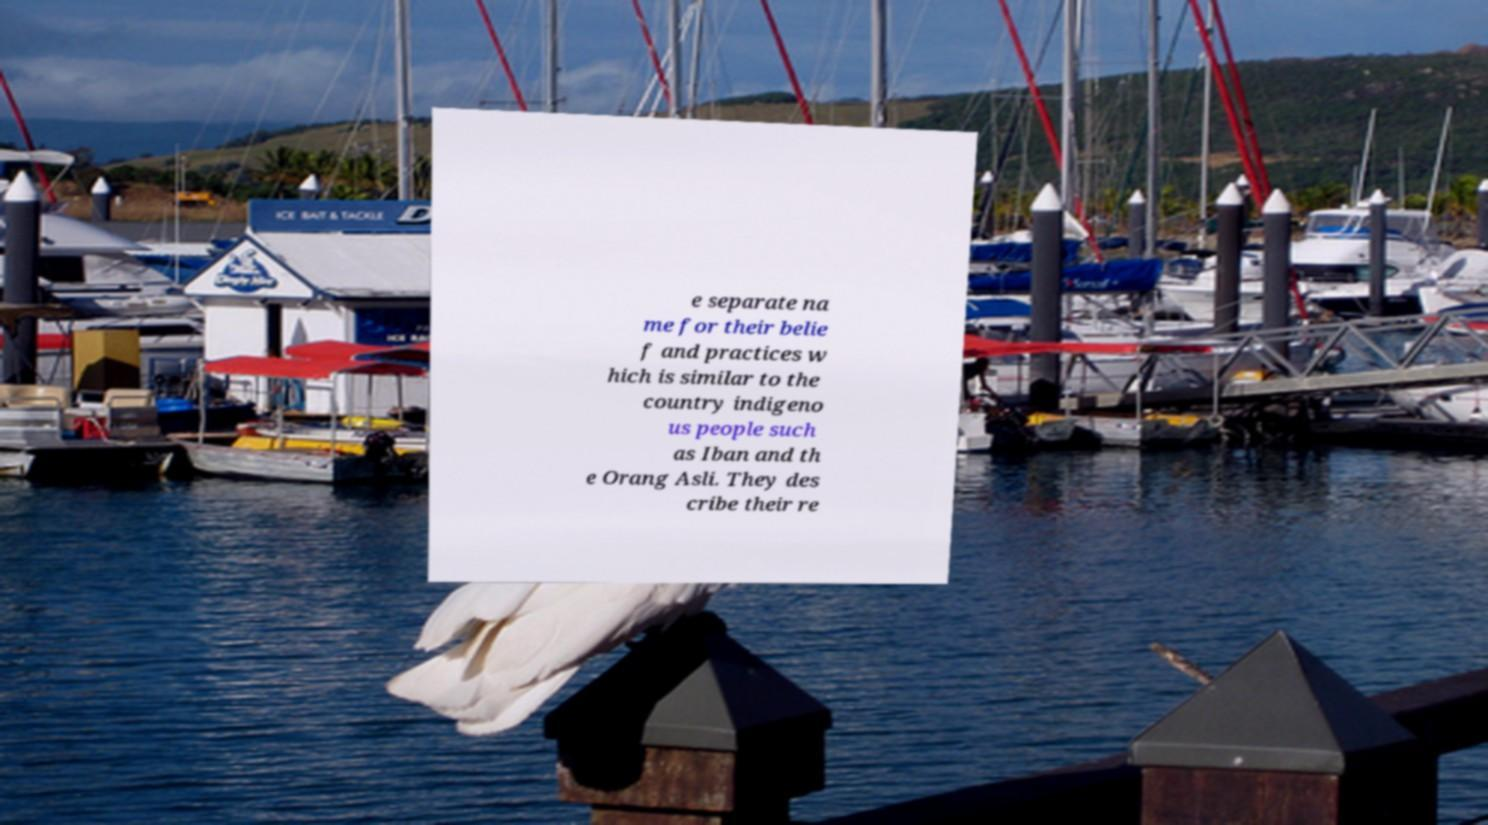Please read and relay the text visible in this image. What does it say? e separate na me for their belie f and practices w hich is similar to the country indigeno us people such as Iban and th e Orang Asli. They des cribe their re 